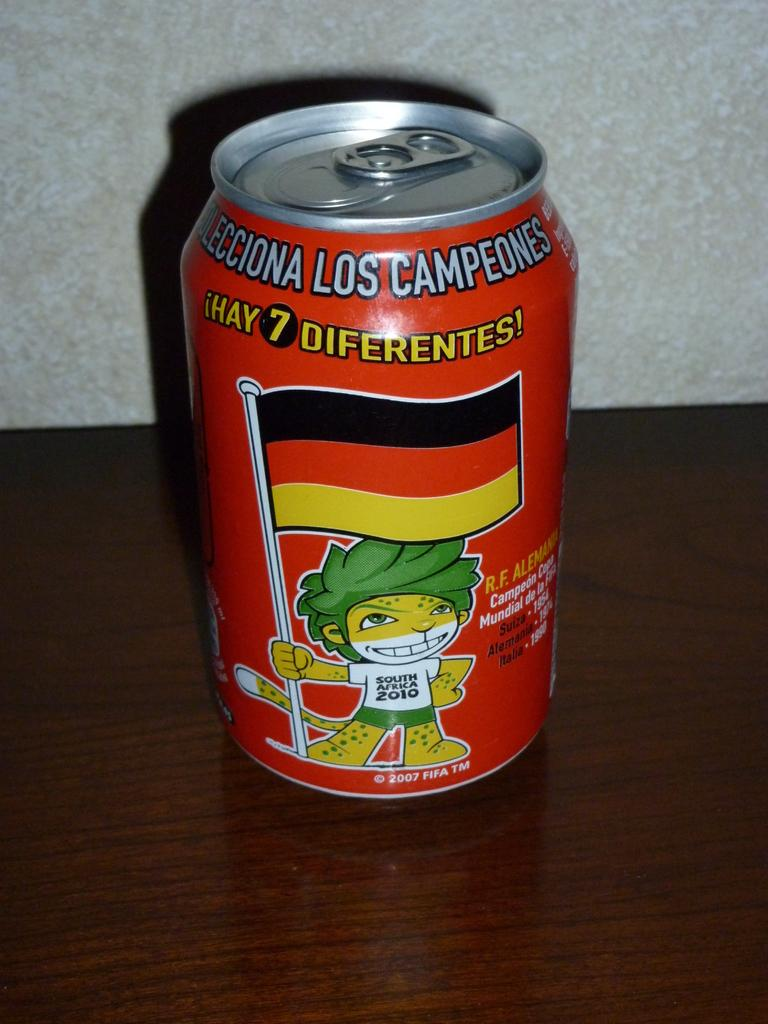<image>
Present a compact description of the photo's key features. A can shows a little cartoon man with "South Africa 2010" on his shirt. 